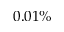<formula> <loc_0><loc_0><loc_500><loc_500>0 . 0 1 \%</formula> 